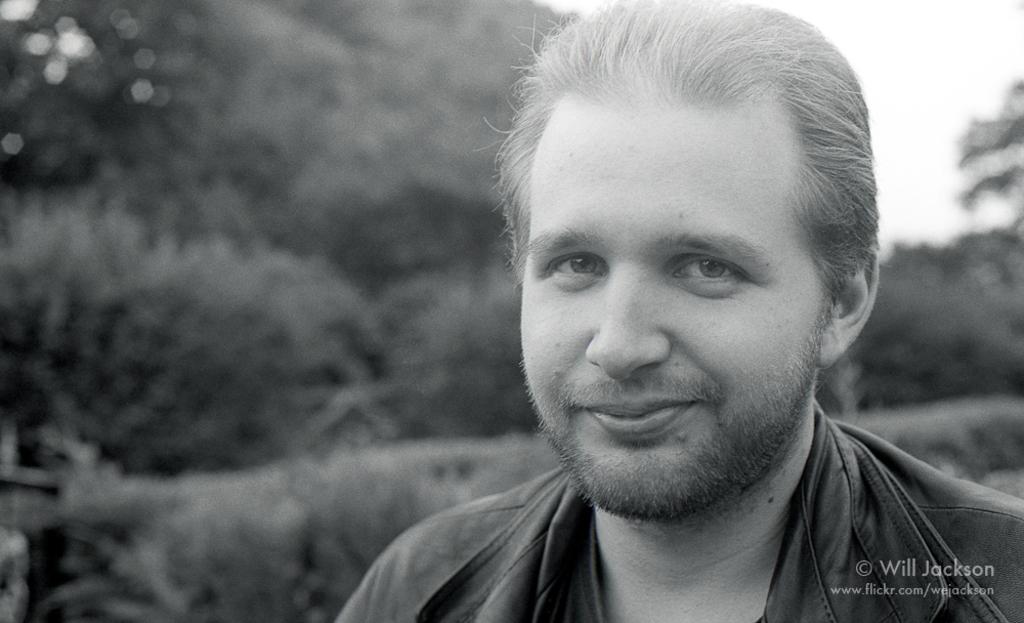Please provide a concise description of this image. In this image we can see a man. In the background we can see trees and sky. 